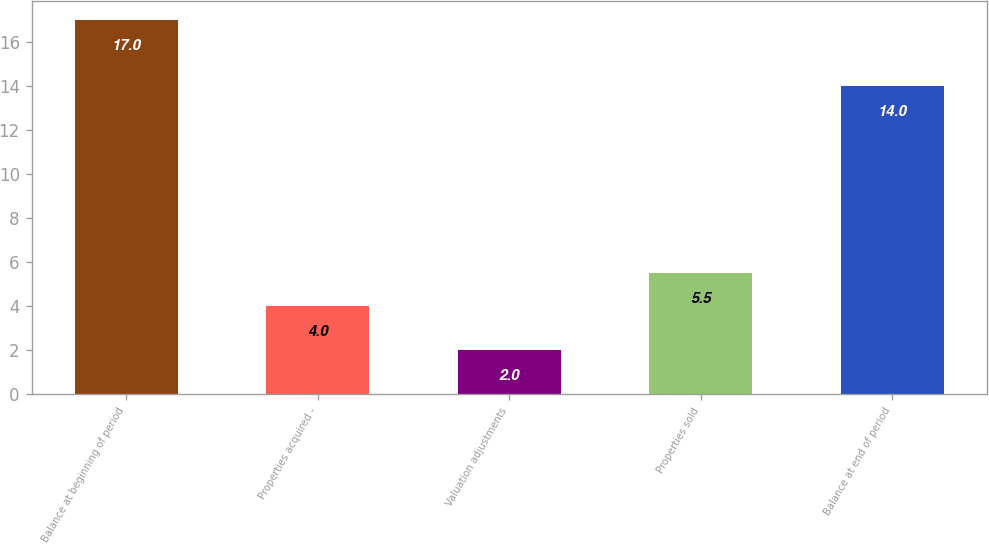<chart> <loc_0><loc_0><loc_500><loc_500><bar_chart><fcel>Balance at beginning of period<fcel>Properties acquired -<fcel>Valuation adjustments<fcel>Properties sold<fcel>Balance at end of period<nl><fcel>17<fcel>4<fcel>2<fcel>5.5<fcel>14<nl></chart> 